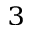Convert formula to latex. <formula><loc_0><loc_0><loc_500><loc_500>^ { 3 }</formula> 